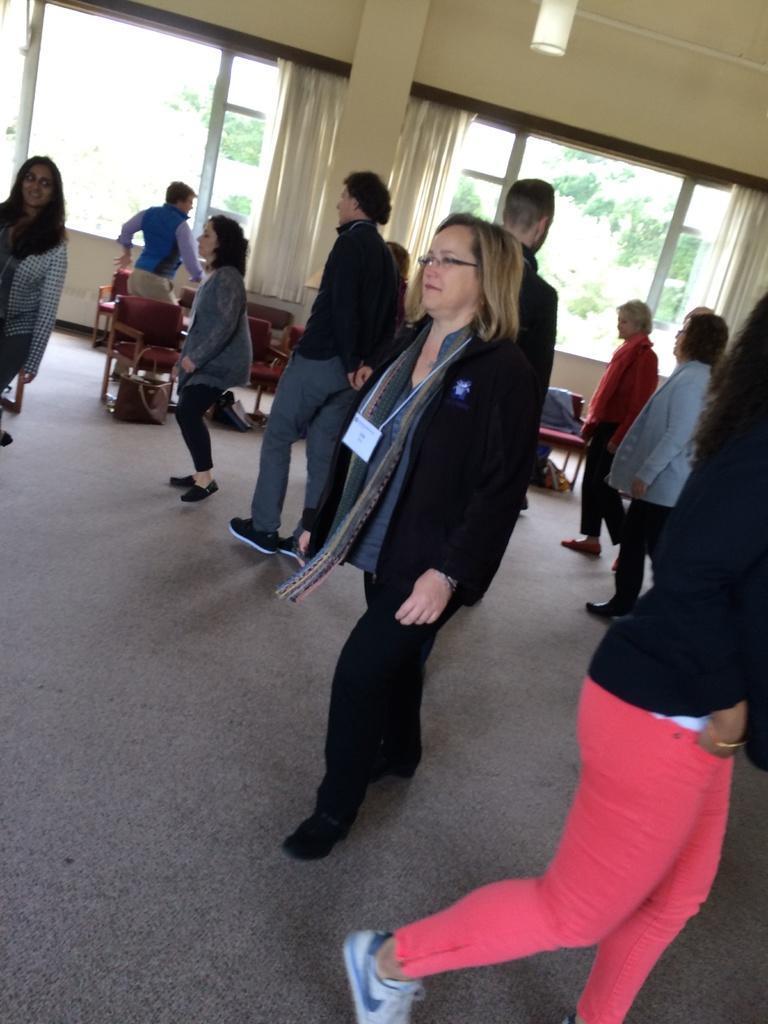How would you summarize this image in a sentence or two? There are so many people walking on floor beside her there are so chairs and windows with curtains. 